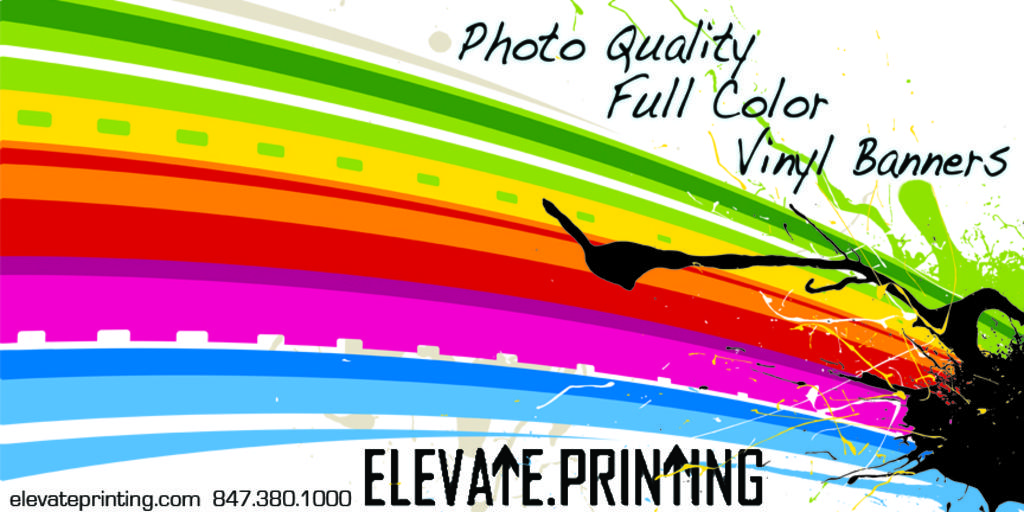What is present in the image that features visual information? There is a poster in the image. How would you describe the appearance of the poster? The poster contains many colors. What type of content is on the poster? There is text on the poster. What year is depicted on the poster? There is no specific year depicted on the poster; it only contains text and colors. Can you describe the zebra's design on the poster? There is no zebra present on the poster; it only features text and colors. 